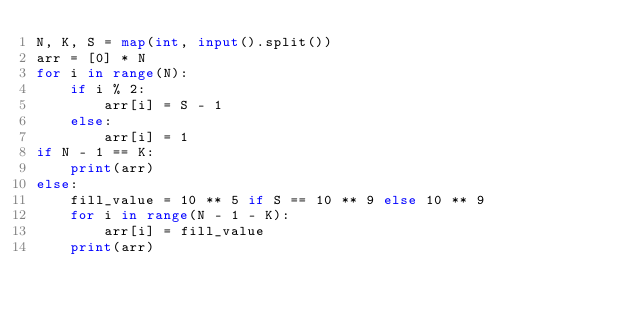Convert code to text. <code><loc_0><loc_0><loc_500><loc_500><_Python_>N, K, S = map(int, input().split())
arr = [0] * N
for i in range(N):
    if i % 2:
        arr[i] = S - 1
    else:
        arr[i] = 1
if N - 1 == K:
    print(arr)
else:
    fill_value = 10 ** 5 if S == 10 ** 9 else 10 ** 9
    for i in range(N - 1 - K):
        arr[i] = fill_value
    print(arr)</code> 